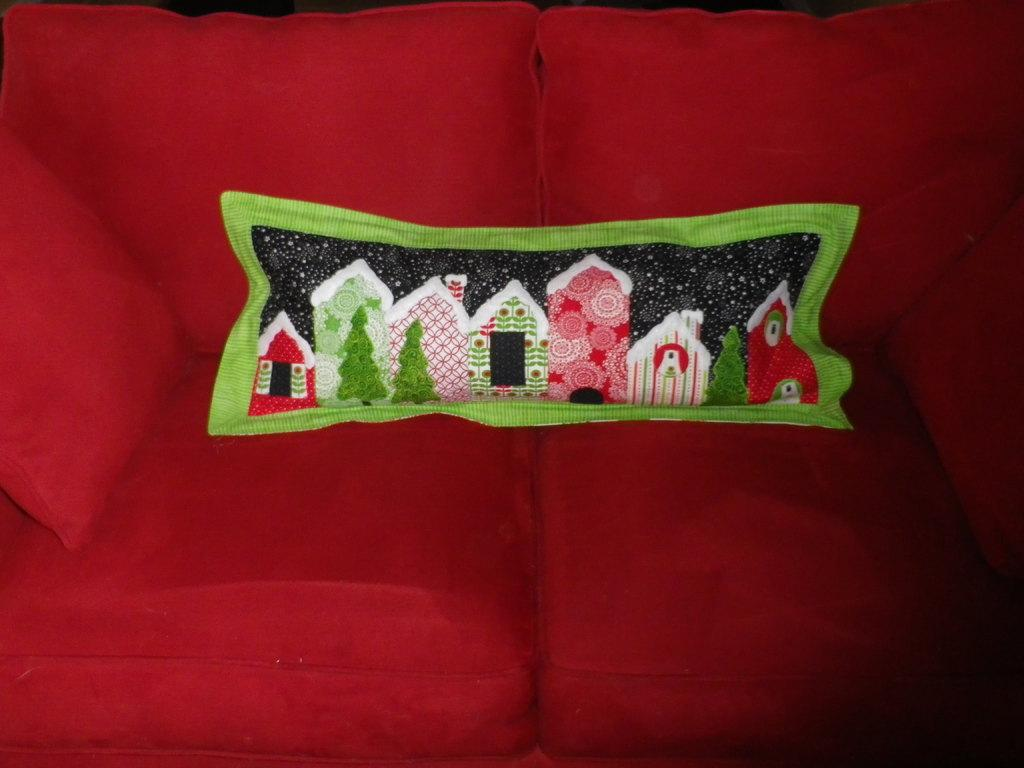What is the main piece of furniture in the image? There is a couch in the center of the image. What color is the couch? The couch is red in color. Are there any accessories on the couch? Yes, there are pillows on the couch. In which direction is the couch curved in the image? The couch is not curved in the image; it is a straight couch. What type of test is being conducted on the couch in the image? There is no test being conducted on the couch in the image; it is simply a couch with pillows. 